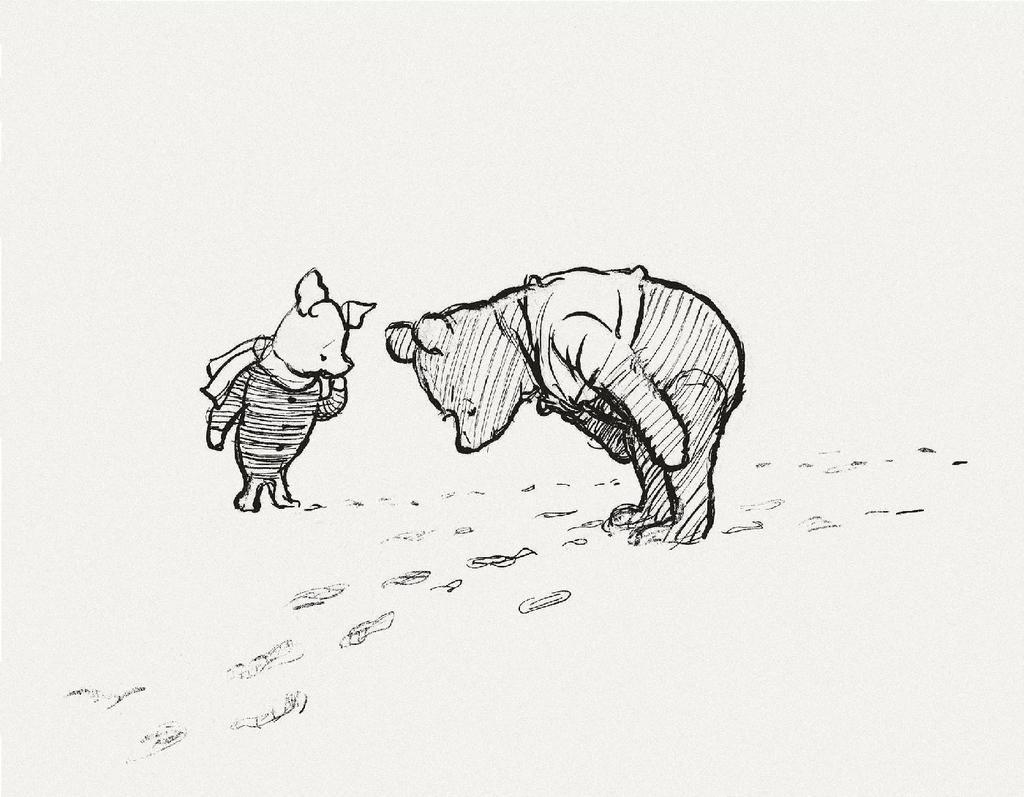Can you describe this image briefly? In the center of this picture we can see the drawing of an animal standing on the ground and bending forward. On the left there is a drawing of another animal standing on the ground and there are some footprints on the ground. 